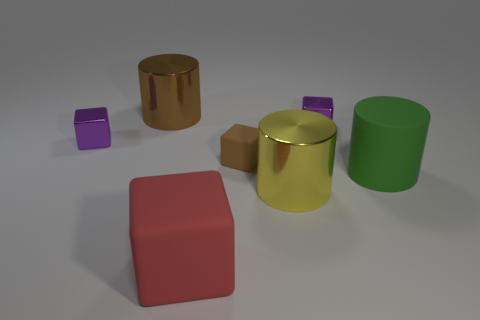How many objects are brown cylinders or objects that are behind the big red matte cube?
Provide a succinct answer. 6. Do the red matte object and the brown metal cylinder have the same size?
Provide a short and direct response. Yes. There is a yellow metallic object; are there any purple metallic cubes to the right of it?
Keep it short and to the point. Yes. There is a cylinder that is on the right side of the big rubber cube and behind the big yellow thing; what is its size?
Provide a succinct answer. Large. What number of things are yellow metal things or tiny purple cubes?
Your response must be concise. 3. There is a brown metallic object; does it have the same size as the red block in front of the big brown shiny cylinder?
Provide a short and direct response. Yes. What size is the shiny cube to the left of the brown metallic cylinder that is to the left of the rubber object in front of the yellow shiny cylinder?
Keep it short and to the point. Small. Are there any tiny brown shiny cylinders?
Offer a very short reply. No. How many shiny cylinders have the same color as the small matte cube?
Ensure brevity in your answer.  1. What number of things are either small purple metallic things to the left of the small brown block or rubber cubes that are behind the yellow thing?
Give a very brief answer. 2. 